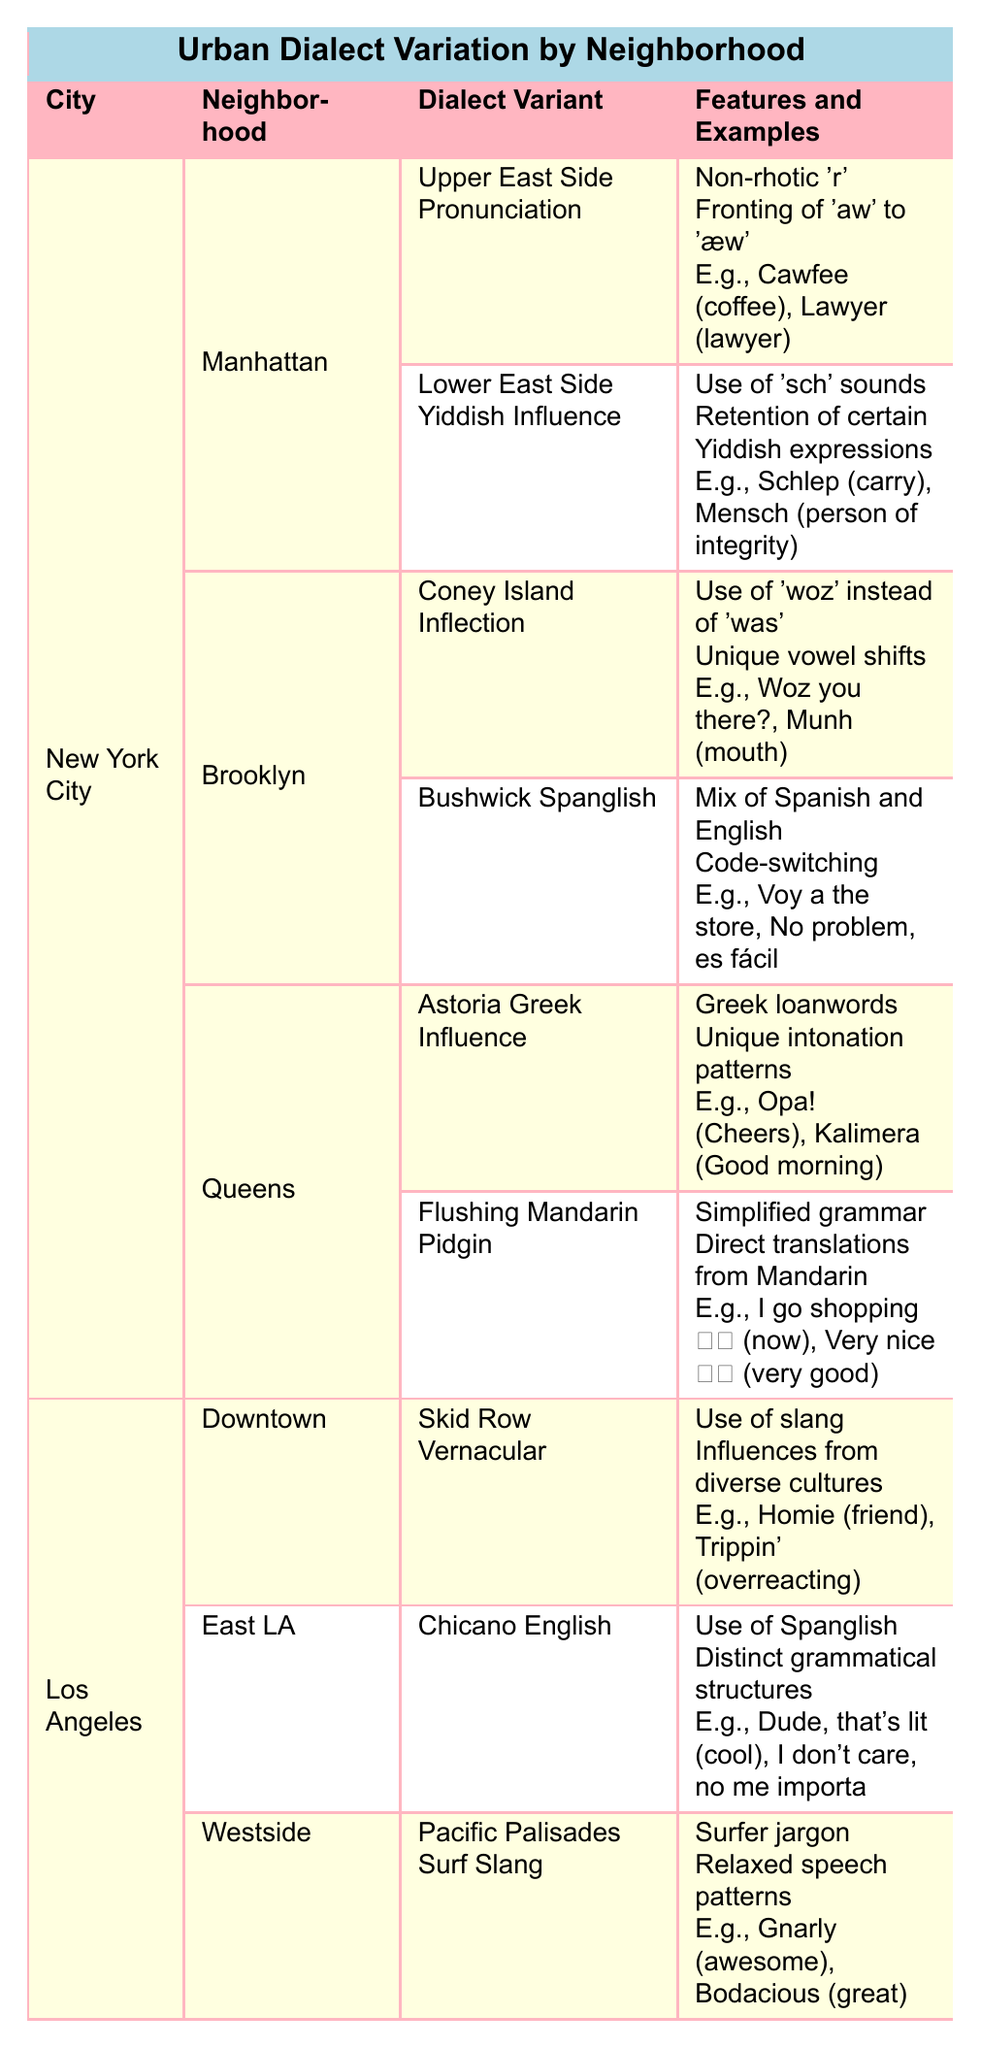What are the dialect variants found in Manhattan? The table lists two dialect variants for Manhattan: Upper East Side Pronunciation and Lower East Side Yiddish Influence.
Answer: Upper East Side Pronunciation, Lower East Side Yiddish Influence Which neighborhood in New York City features the dialect variant "Bushwick Spanglish"? The table indicates that Bushwick Spanglish is found in the Brooklyn neighborhood of New York City.
Answer: Brooklyn True or False: "Gnarly" is an example from the Pacific Palisades Surf Slang. The table shows that "Gnarly" is indeed an example listed under the Pacific Palisades Surf Slang dialect variant.
Answer: True How many dialect variants are there in Los Angeles? The table shows that there are three dialect variants listed for Los Angeles: Skid Row Vernacular, Chicano English, and Pacific Palisades Surf Slang. Thus, the count is three.
Answer: Three Which dialect variant from Queens involves simplified grammar? The dialect variant from Queens that involves simplified grammar is Flushing Mandarin Pidgin, as shown in the table.
Answer: Flushing Mandarin Pidgin What is the total number of dialect features mentioned for the "Coney Island Inflection"? The table states that Coney Island Inflection has two features: use of 'woz' instead of 'was' and unique vowel shifts. Thus, the total is two.
Answer: Two Which city has a dialect variant that includes influences from diverse cultures? The table reveals that Los Angeles has a dialect variant called Skid Row Vernacular, which includes influences from diverse cultures. Therefore, the answer is Los Angeles.
Answer: Los Angeles How many dialect variants in total are listed for New York City? Summing up the dialect variants from Manhattan (2), Brooklyn (2), and Queens (2), the total is 2 + 2 + 2 = 6 dialect variants for New York City.
Answer: Six Is "Opa!" used in the East LA neighborhood? The table specifies that "Opa!" is used in the Astoria Greek Influence dialect variant, which is associated with Queens, not East LA, making the statement false.
Answer: False 